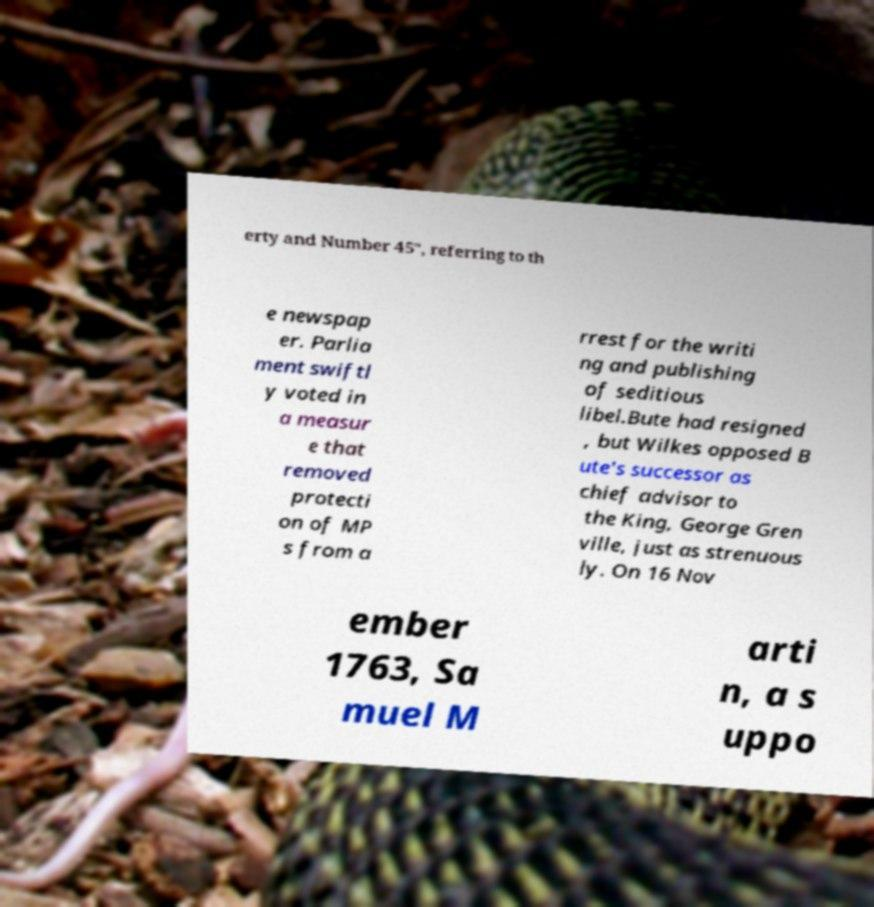Can you read and provide the text displayed in the image?This photo seems to have some interesting text. Can you extract and type it out for me? erty and Number 45", referring to th e newspap er. Parlia ment swiftl y voted in a measur e that removed protecti on of MP s from a rrest for the writi ng and publishing of seditious libel.Bute had resigned , but Wilkes opposed B ute's successor as chief advisor to the King, George Gren ville, just as strenuous ly. On 16 Nov ember 1763, Sa muel M arti n, a s uppo 